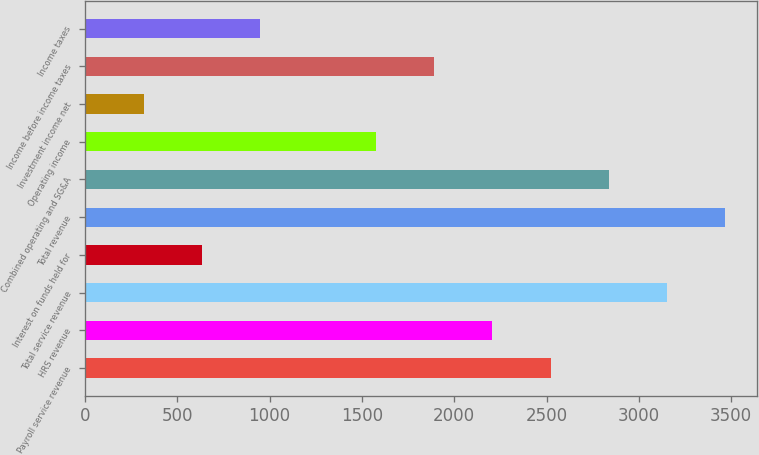<chart> <loc_0><loc_0><loc_500><loc_500><bar_chart><fcel>Payroll service revenue<fcel>HRS revenue<fcel>Total service revenue<fcel>Interest on funds held for<fcel>Total revenue<fcel>Combined operating and SG&A<fcel>Operating income<fcel>Investment income net<fcel>Income before income taxes<fcel>Income taxes<nl><fcel>2521.51<fcel>2206.6<fcel>3151.33<fcel>632.07<fcel>3466.24<fcel>2836.42<fcel>1576.79<fcel>317.16<fcel>1891.69<fcel>946.98<nl></chart> 